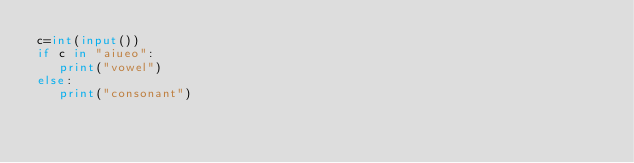Convert code to text. <code><loc_0><loc_0><loc_500><loc_500><_Python_>c=int(input())
if c in "aiueo":
   print("vowel")
else:
   print("consonant")</code> 